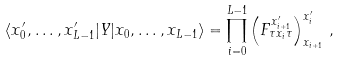Convert formula to latex. <formula><loc_0><loc_0><loc_500><loc_500>\langle x _ { 0 } ^ { \prime } , \dots , x _ { L - 1 } ^ { \prime } | Y | x _ { 0 } , \dots , x _ { L - 1 } \rangle = \prod _ { i = 0 } ^ { L - 1 } \left ( F ^ { x ^ { \prime } _ { i + 1 } } _ { \tau x _ { i } \tau } \right ) ^ { x _ { i } ^ { \prime } } _ { x _ { i + 1 } } \, ,</formula> 